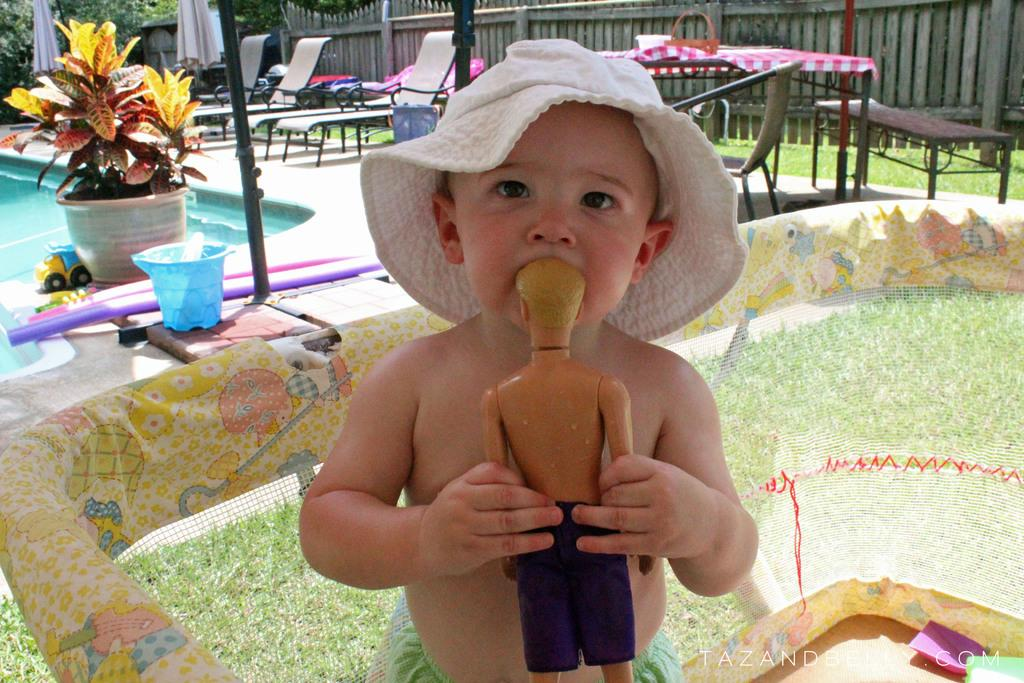What is the main subject of the image? The main subject of the image is a kid. What is the kid doing in the image? The kid is standing and holding a man statue in his hand. What can be seen in the background of the image? There is a swimming pool in the background of the image. What objects are present on the road in the image? Chairs are present on the road in the image. What type of credit card is the kid using to purchase the man statue in the image? There is no credit card or purchase depicted in the image; the kid is simply holding a man statue in his hand. What is the topic of the discussion between the kid and the man statue in the image? There is no discussion between the kid and the man statue in the image; the man statue is a stationary object. 